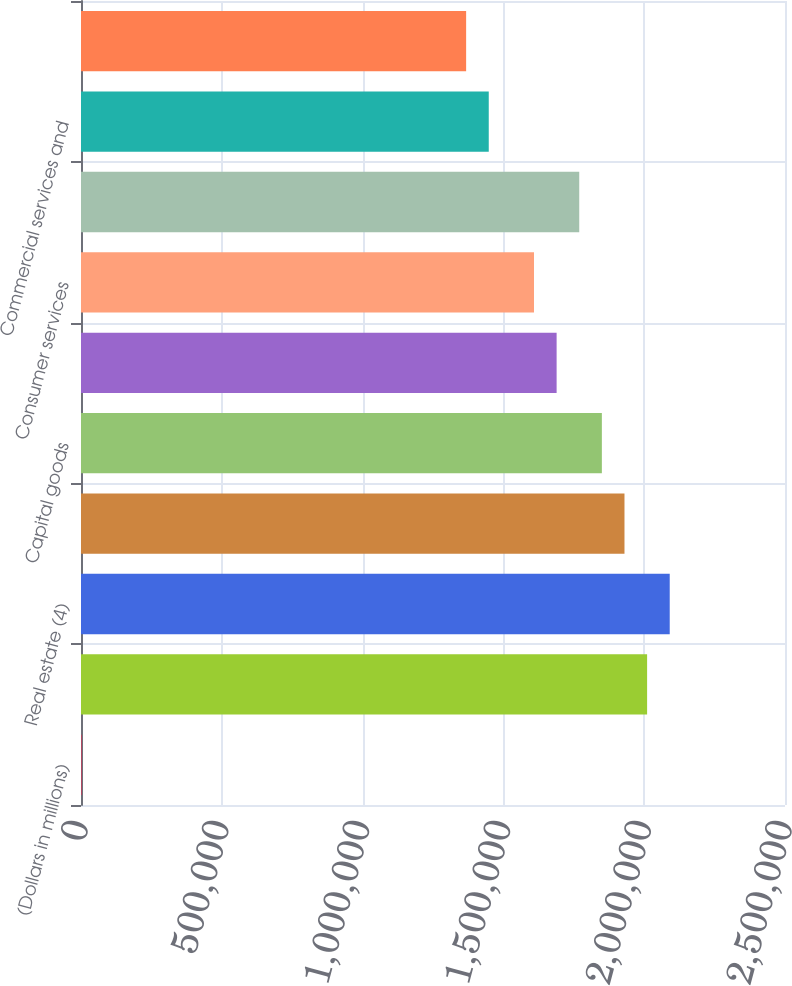Convert chart to OTSL. <chart><loc_0><loc_0><loc_500><loc_500><bar_chart><fcel>(Dollars in millions)<fcel>Diversified financials<fcel>Real estate (4)<fcel>Government and public<fcel>Capital goods<fcel>Healthcare equipment and<fcel>Consumer services<fcel>Retailing<fcel>Commercial services and<fcel>Individuals and trusts<nl><fcel>2008<fcel>2.01032e+06<fcel>2.09065e+06<fcel>1.92999e+06<fcel>1.84965e+06<fcel>1.68899e+06<fcel>1.60866e+06<fcel>1.76932e+06<fcel>1.44799e+06<fcel>1.36766e+06<nl></chart> 